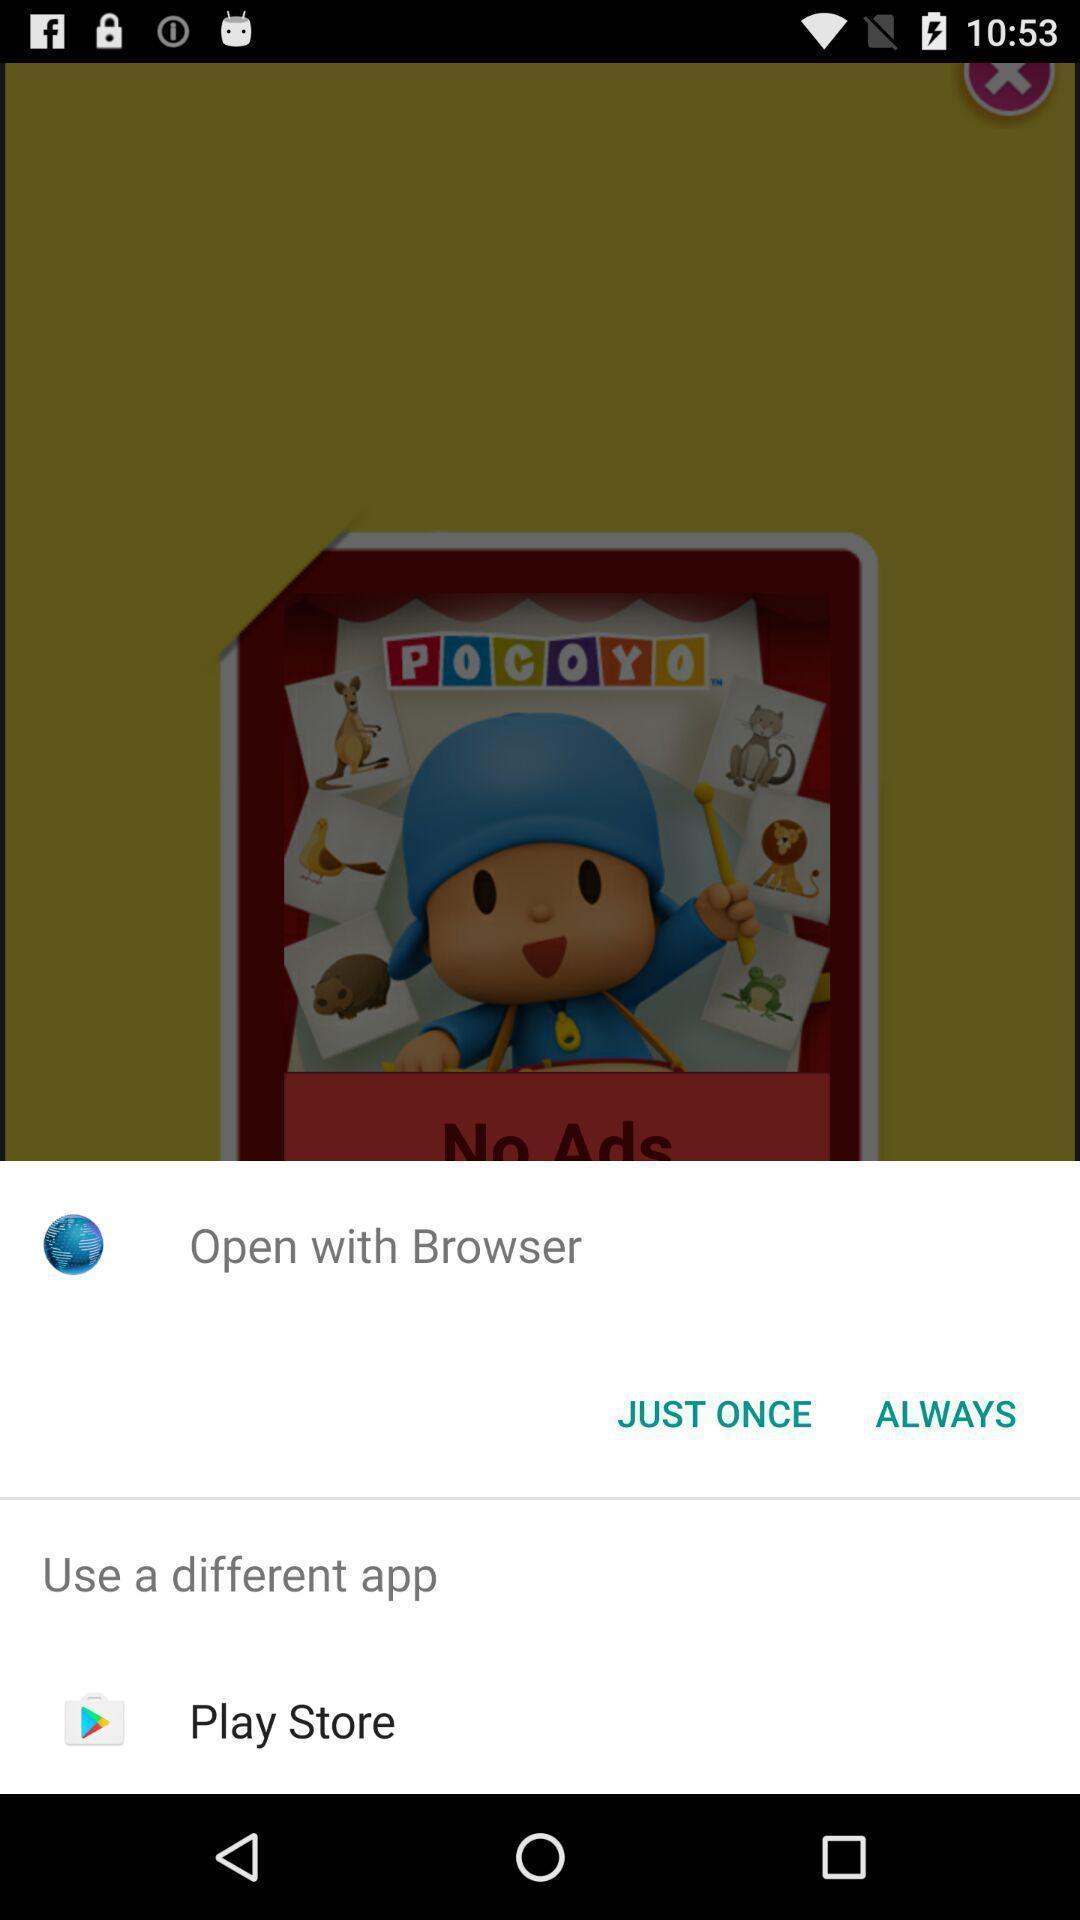Summarize the information in this screenshot. Pop-up showing options to open a browser. 